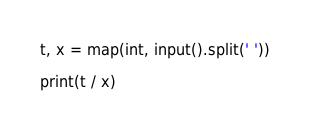Convert code to text. <code><loc_0><loc_0><loc_500><loc_500><_Python_>t, x = map(int, input().split(' '))

print(t / x)
</code> 